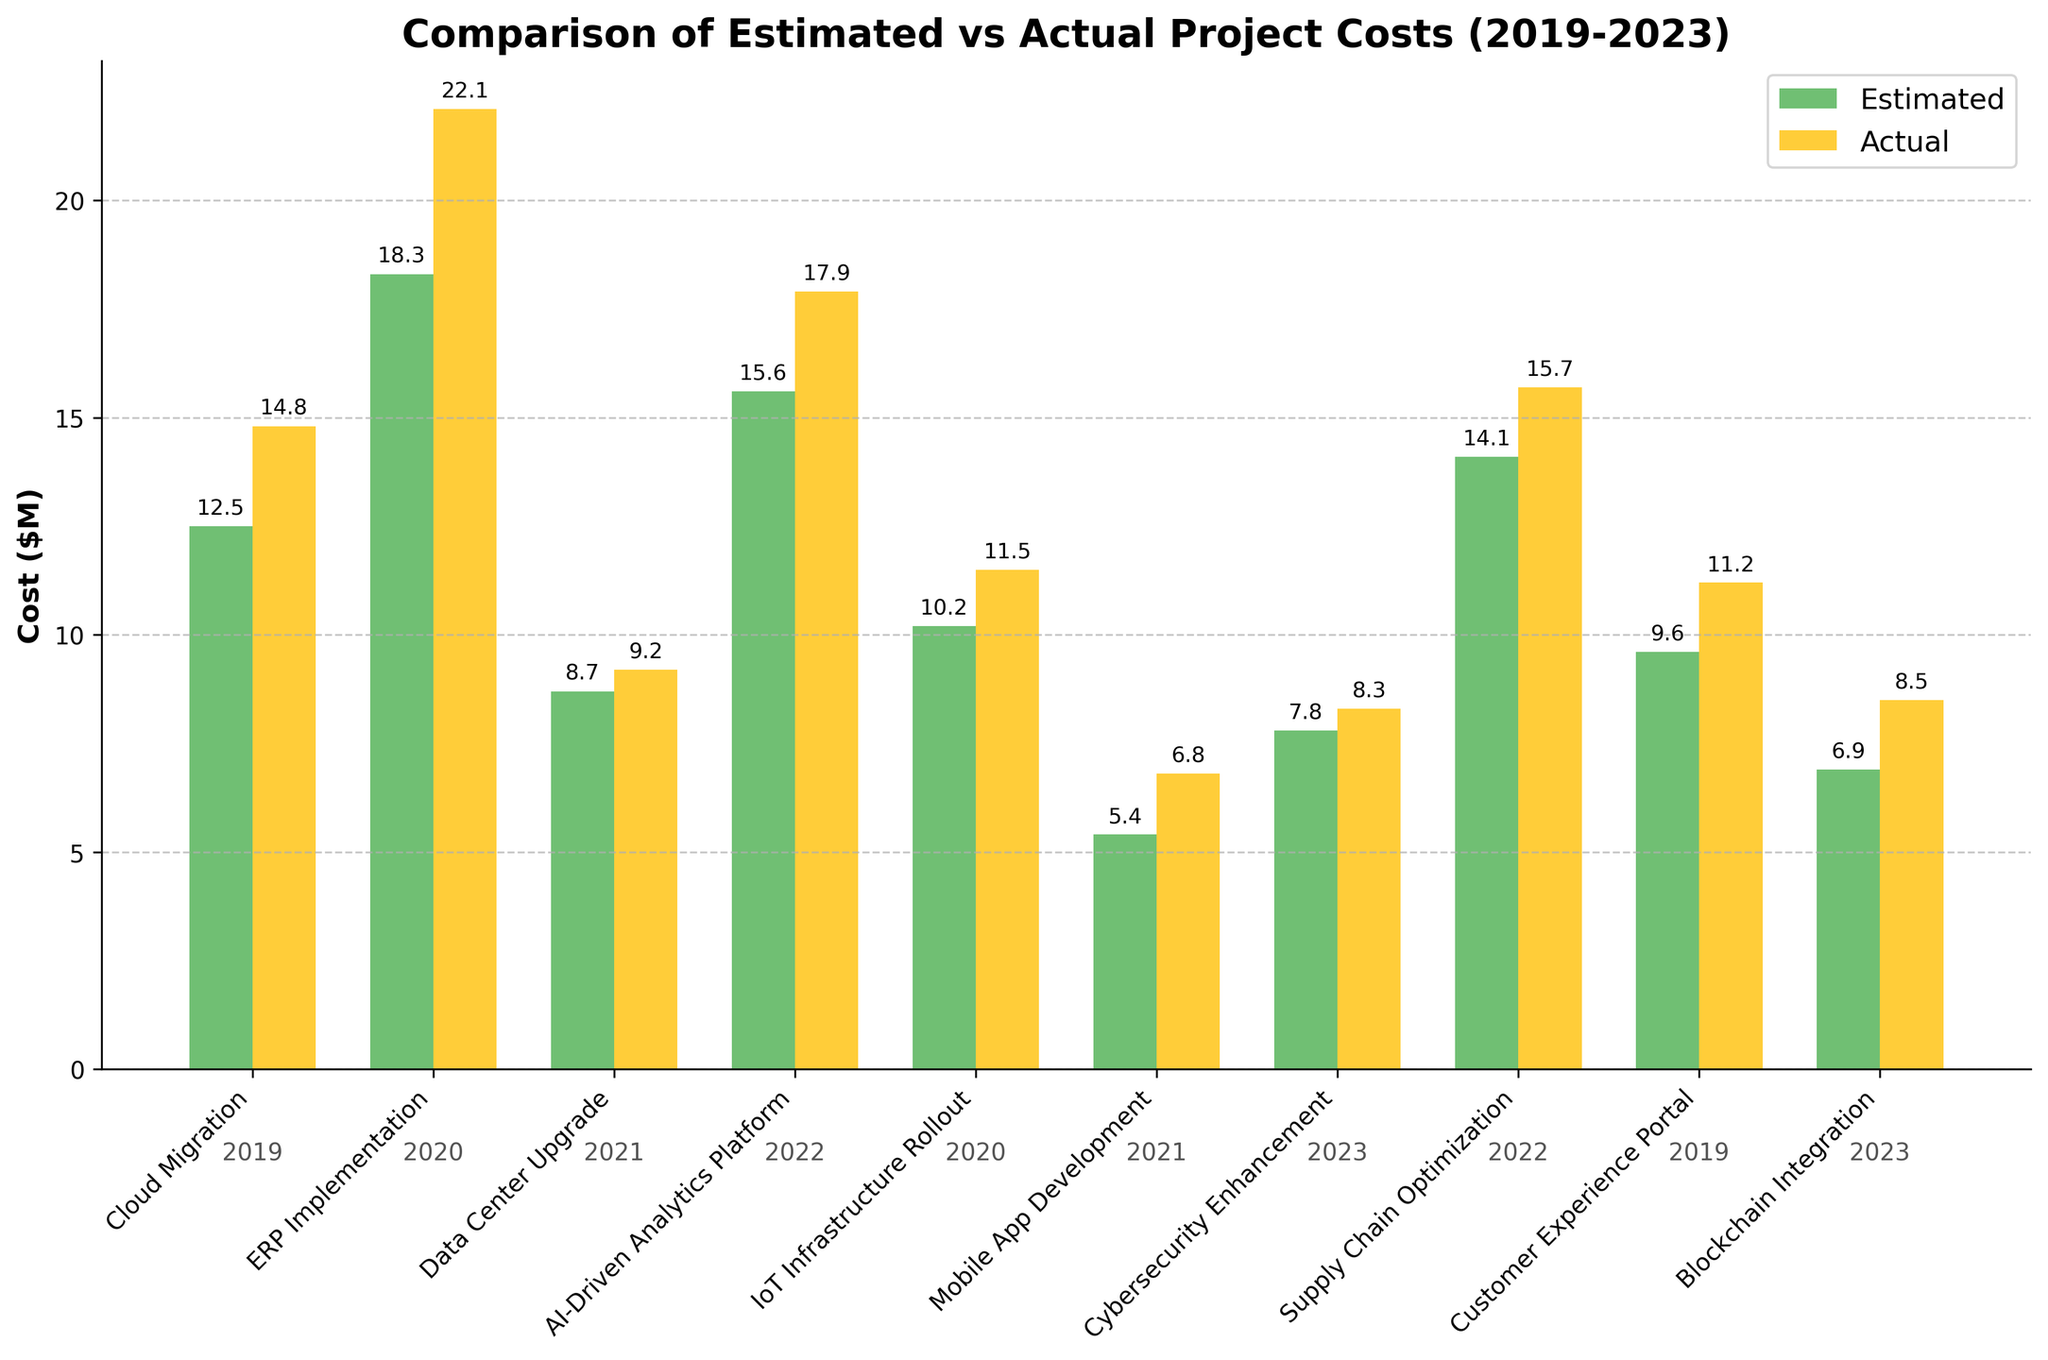Which project had the largest difference between estimated and actual costs? To find the largest difference, calculate the absolute difference between estimated and actual costs for each project. The largest difference is found for "ERP Implementation" with (22.1 - 18.3) = 3.8 million dollars.
Answer: ERP Implementation Which year had the most projects exceeding their estimated costs? Check each project's actual vs. estimated cost by year. The years 2020 and 2022 both have two projects exceeding their estimated costs: "ERP Implementation" and "IoT Infrastructure Rollout" in 2020, and "AI-Driven Analytics Platform" and "Supply Chain Optimization" in 2022.
Answer: 2020 and 2022 Did the "Customer Experience Portal" project cost more or less than "Mobile App Development"? Compare the actual costs of both projects: "Customer Experience Portal" is $11.2M and "Mobile App Development" is $6.8M. Hence, "Customer Experience Portal" cost more.
Answer: Customer Experience Portal cost more What was the total actual cost for projects carried out in 2021? Sum the actual costs of projects from 2021: "Data Center Upgrade" ($9.2M) and "Mobile App Development" ($6.8M). The total is 9.2 + 6.8 = 16M dollars.
Answer: $16M Are most of the projects shown underestimated or overestimated in their costs? By comparing the bars, we find that the actual cost bar is higher for most projects, indicating most projects are overestimated in their costs. Count: Overestimated = 8, Underestimated = 2.
Answer: Overestimated For the project "Blockchain Integration," how much was the actual cost greater than the estimated cost? Calculate the difference between actual and estimated costs for "Blockchain Integration": (8.5 - 6.9) million dollars.
Answer: $1.6M Which project had the smallest variance between estimated and actual costs? Find the absolute differences and identify the smallest one: "Data Center Upgrade" with a difference of (9.2 - 8.7) = 0.5 million dollars.
Answer: Data Center Upgrade In which year was the "Cybersecurity Enhancement" project conducted, and was its actual cost greater than estimated? The year is annotated below the bar for "Cybersecurity Enhancement," showing 2023, and actual cost (8.3) is greater than estimated (7.8).
Answer: 2023, Yes What is the average estimated cost for projects executed in 2019? Look at the estimated costs for projects from 2019: "Cloud Migration" ($12.5M) and "Customer Experience Portal" ($9.6M). Average is (12.5 + 9.6) / 2 = 11.05M dollars.
Answer: $11.05M Which projects had actual costs exceeding $15 million? Identify projects with actual costs above $15M: "ERP Implementation," "AI-Driven Analytics Platform," and "Supply Chain Optimization"
Answer: ERP Implementation, AI-Driven Analytics Platform, Supply Chain Optimization 